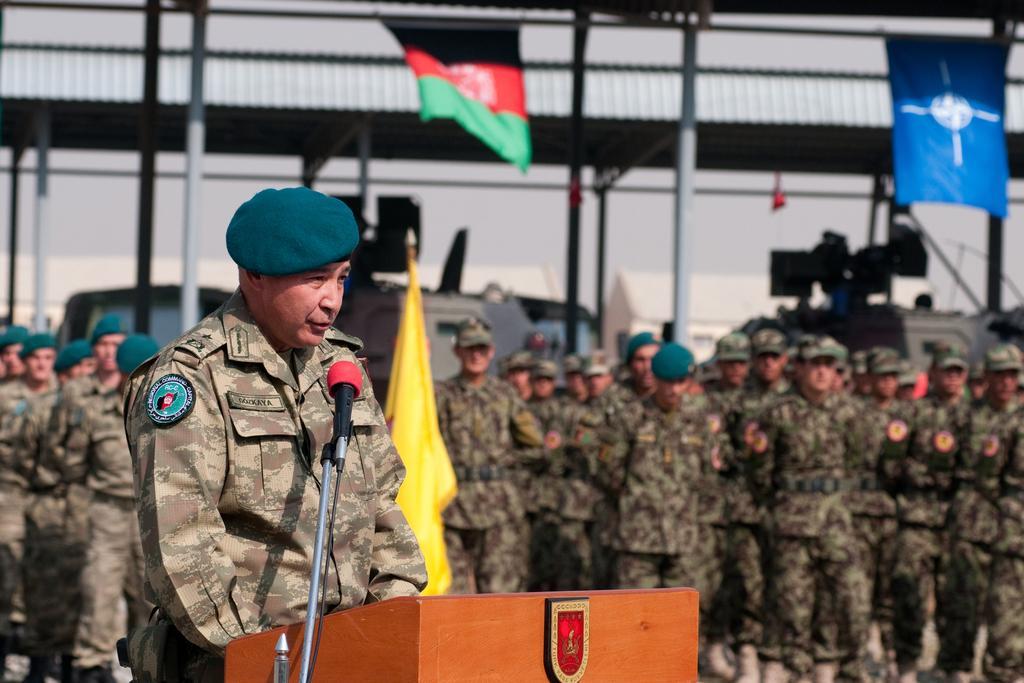Please provide a concise description of this image. In this image we can see a man is standing. He is wearing an army uniform and cap. In front of him, we can see a podium, stand and mic. In the background, we can see so many men are standing and wearing army uniforms. We can see flags, poles, vehicles, buildings, shelter and the sky. 